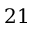<formula> <loc_0><loc_0><loc_500><loc_500>2 1</formula> 